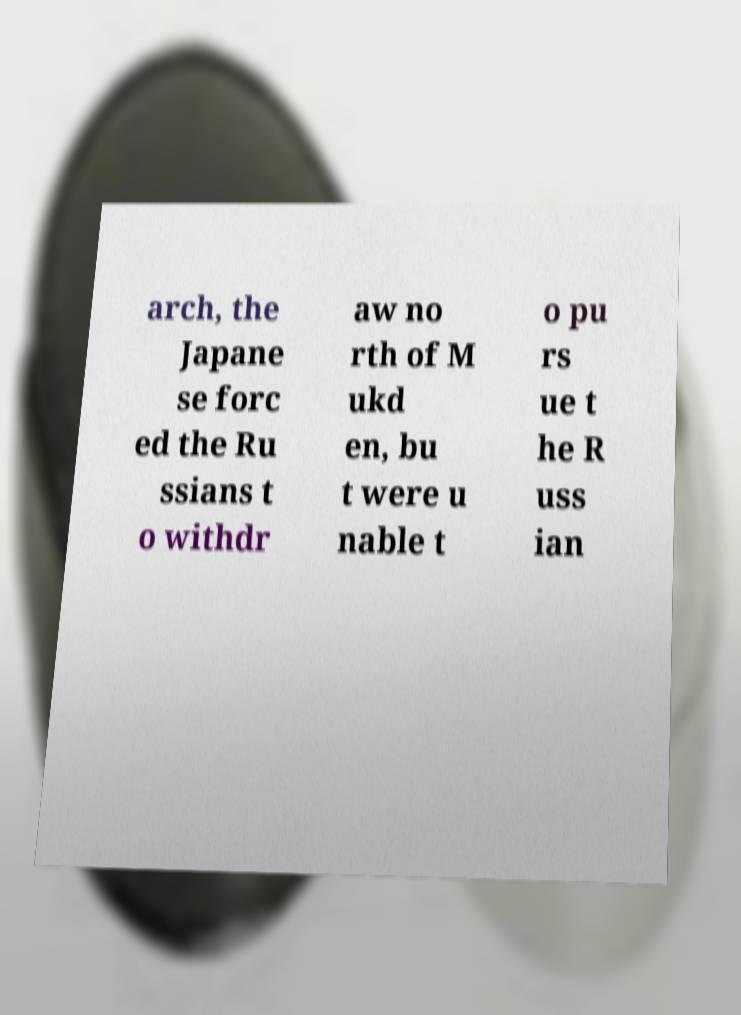Could you extract and type out the text from this image? arch, the Japane se forc ed the Ru ssians t o withdr aw no rth of M ukd en, bu t were u nable t o pu rs ue t he R uss ian 